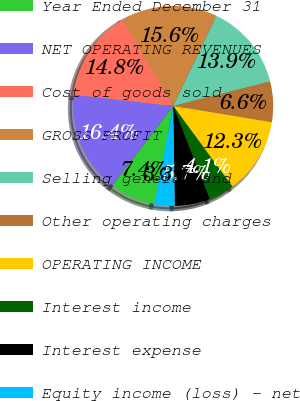<chart> <loc_0><loc_0><loc_500><loc_500><pie_chart><fcel>Year Ended December 31<fcel>NET OPERATING REVENUES<fcel>Cost of goods sold<fcel>GROSS PROFIT<fcel>Selling general and<fcel>Other operating charges<fcel>OPERATING INCOME<fcel>Interest income<fcel>Interest expense<fcel>Equity income (loss) - net<nl><fcel>7.38%<fcel>16.39%<fcel>14.75%<fcel>15.57%<fcel>13.93%<fcel>6.56%<fcel>12.3%<fcel>4.1%<fcel>5.74%<fcel>3.28%<nl></chart> 